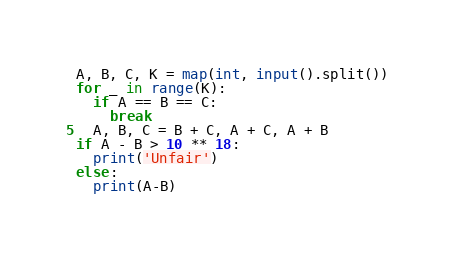Convert code to text. <code><loc_0><loc_0><loc_500><loc_500><_Python_>A, B, C, K = map(int, input().split())
for _ in range(K):
  if A == B == C:
    break
  A, B, C = B + C, A + C, A + B
if A - B > 10 ** 18:
  print('Unfair')
else:
  print(A-B)</code> 